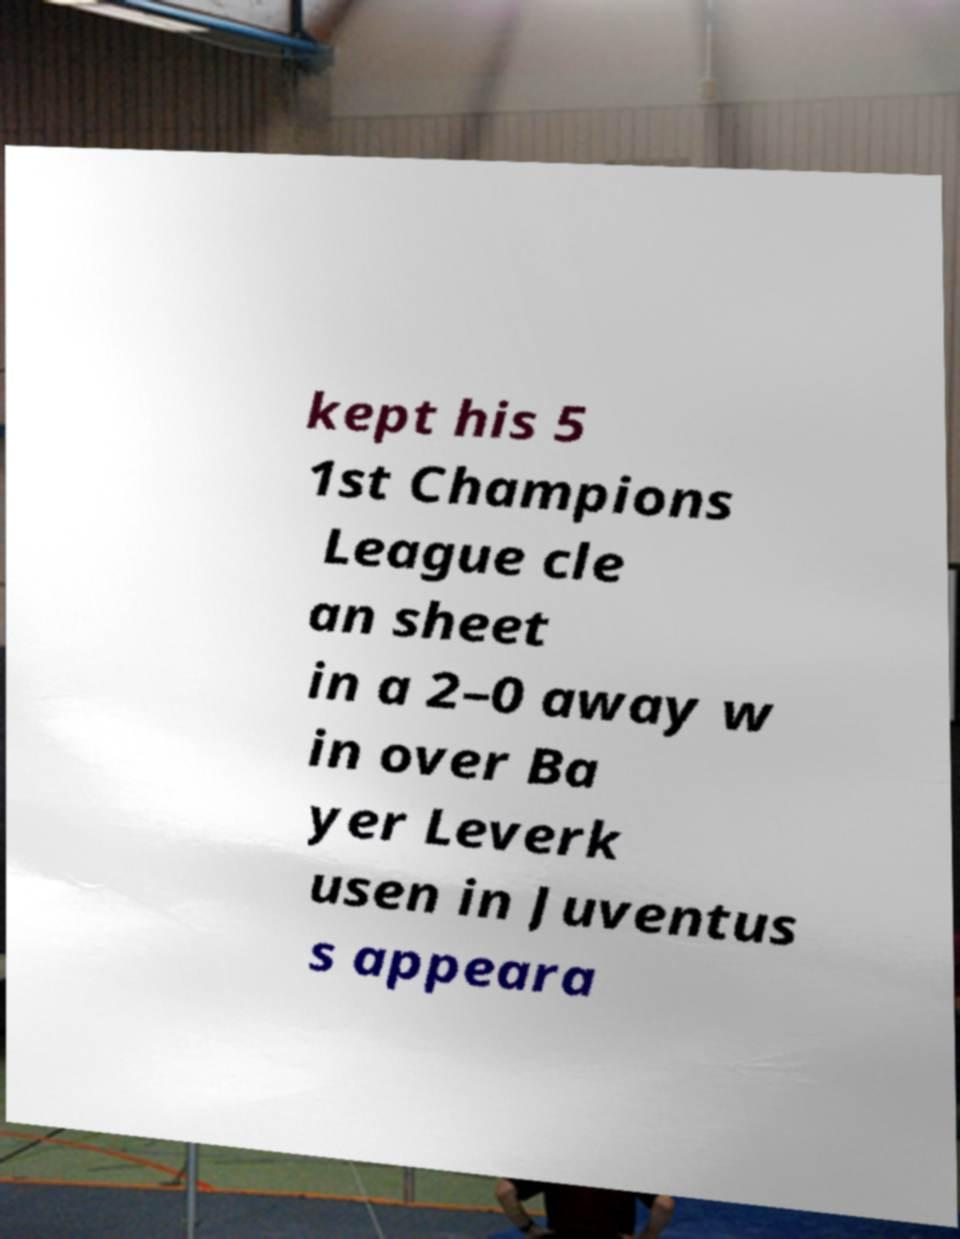Please read and relay the text visible in this image. What does it say? kept his 5 1st Champions League cle an sheet in a 2–0 away w in over Ba yer Leverk usen in Juventus s appeara 